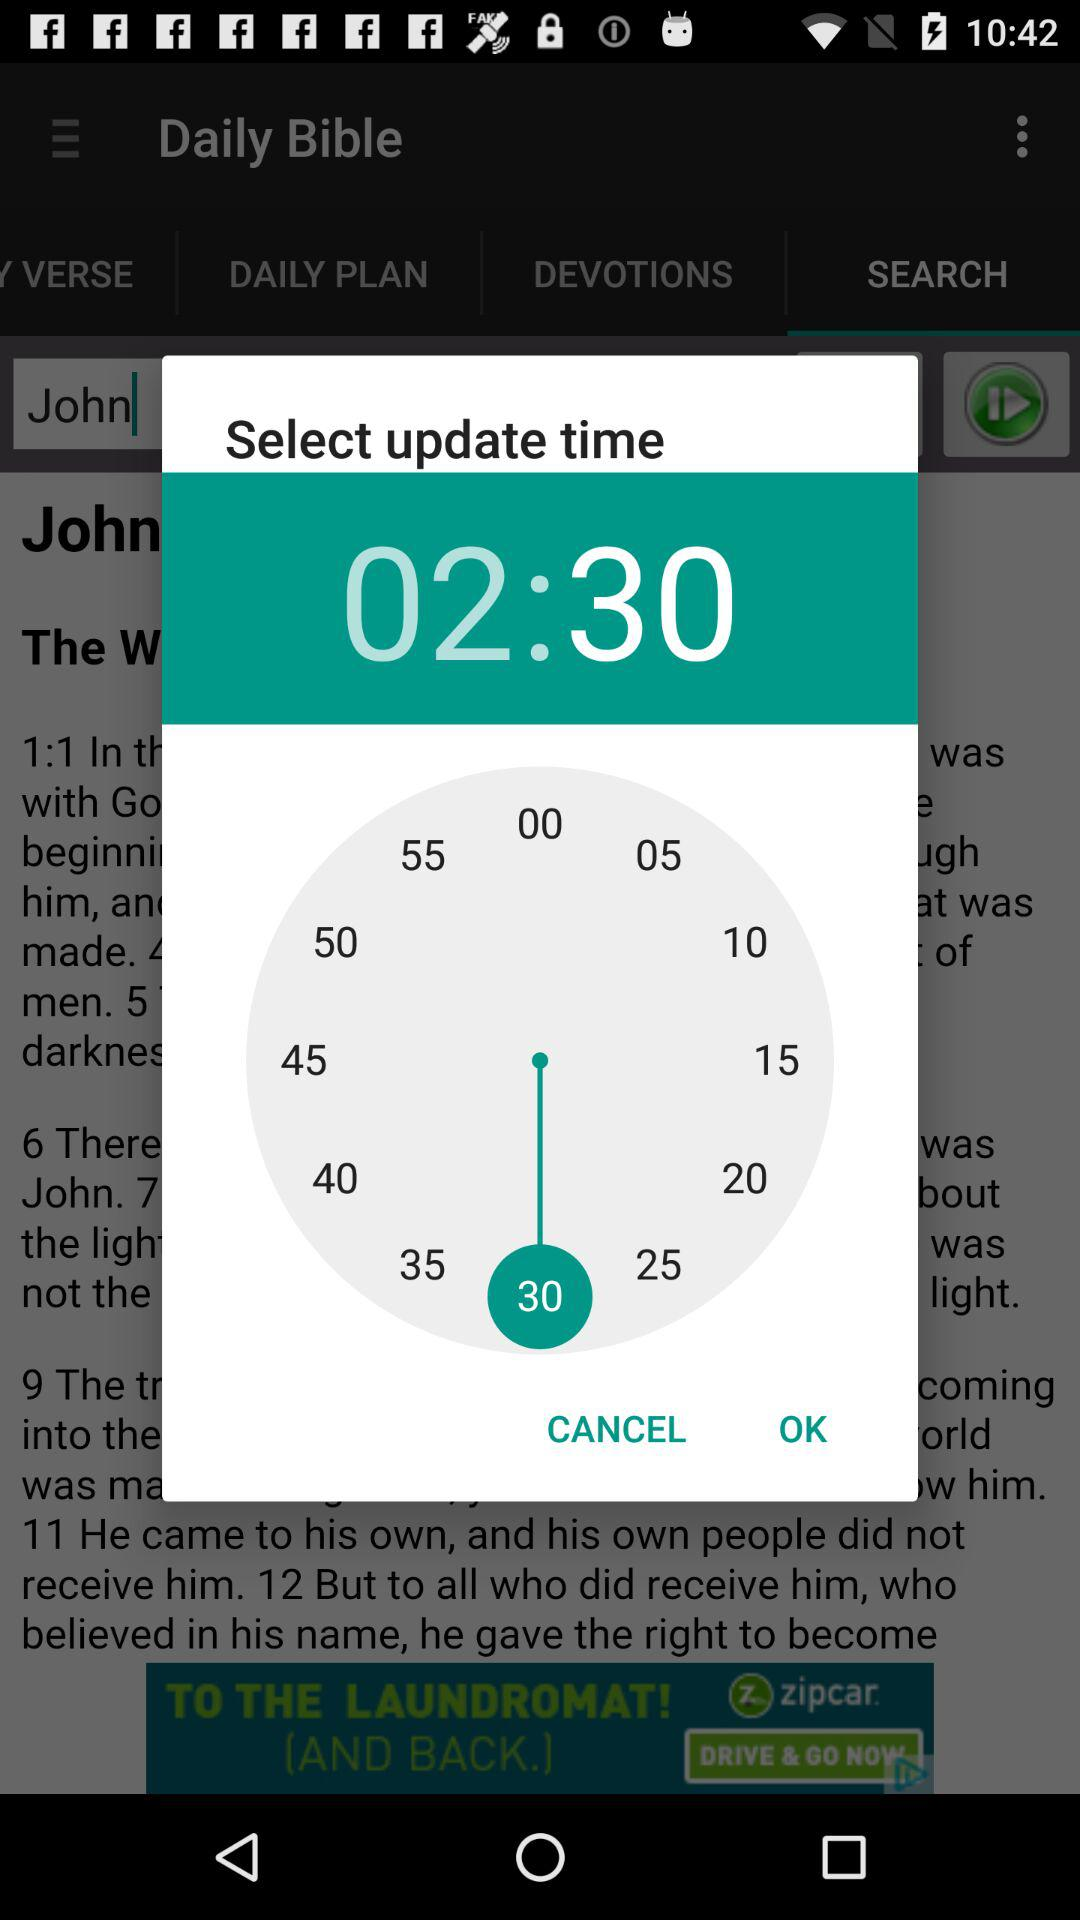Which tab is selected? The selected tab is "SEARCH". 